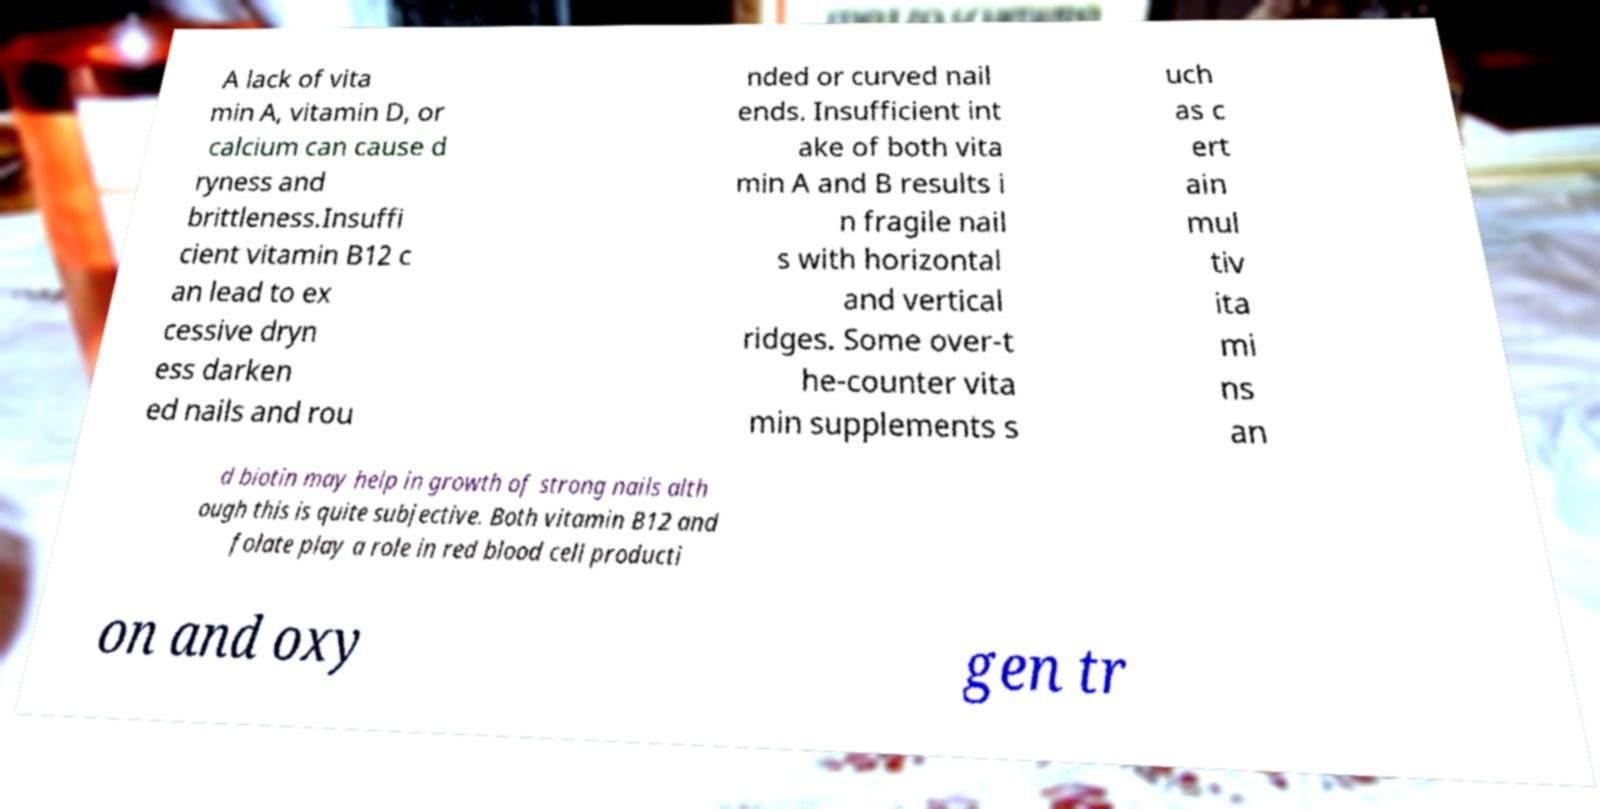Can you accurately transcribe the text from the provided image for me? A lack of vita min A, vitamin D, or calcium can cause d ryness and brittleness.Insuffi cient vitamin B12 c an lead to ex cessive dryn ess darken ed nails and rou nded or curved nail ends. Insufficient int ake of both vita min A and B results i n fragile nail s with horizontal and vertical ridges. Some over-t he-counter vita min supplements s uch as c ert ain mul tiv ita mi ns an d biotin may help in growth of strong nails alth ough this is quite subjective. Both vitamin B12 and folate play a role in red blood cell producti on and oxy gen tr 